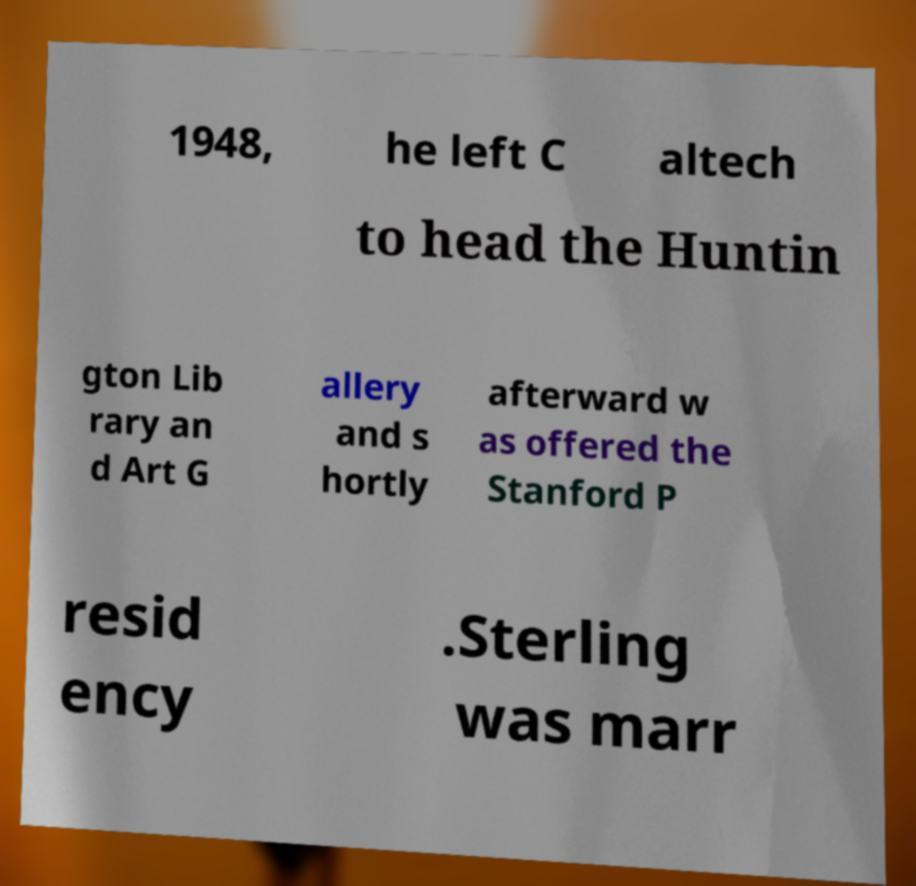I need the written content from this picture converted into text. Can you do that? 1948, he left C altech to head the Huntin gton Lib rary an d Art G allery and s hortly afterward w as offered the Stanford P resid ency .Sterling was marr 